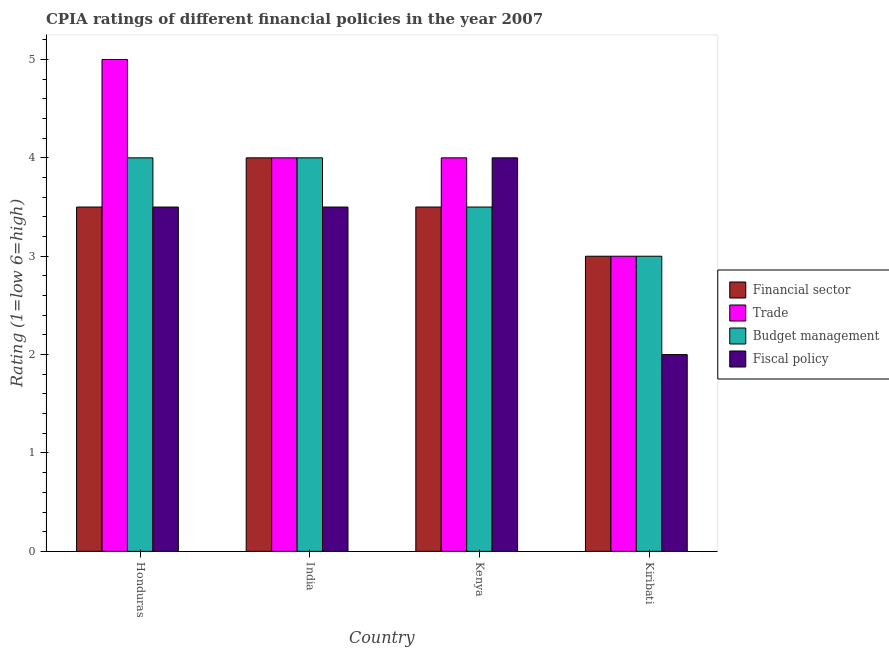How many different coloured bars are there?
Your answer should be compact. 4. Are the number of bars per tick equal to the number of legend labels?
Offer a terse response. Yes. Are the number of bars on each tick of the X-axis equal?
Your answer should be very brief. Yes. How many bars are there on the 1st tick from the left?
Provide a succinct answer. 4. How many bars are there on the 3rd tick from the right?
Keep it short and to the point. 4. What is the label of the 4th group of bars from the left?
Offer a terse response. Kiribati. In how many cases, is the number of bars for a given country not equal to the number of legend labels?
Your answer should be very brief. 0. What is the cpia rating of budget management in Kenya?
Ensure brevity in your answer.  3.5. Across all countries, what is the maximum cpia rating of fiscal policy?
Offer a very short reply. 4. In which country was the cpia rating of fiscal policy maximum?
Your answer should be very brief. Kenya. In which country was the cpia rating of fiscal policy minimum?
Your response must be concise. Kiribati. What is the total cpia rating of budget management in the graph?
Keep it short and to the point. 14.5. What is the difference between the cpia rating of budget management in Kiribati and the cpia rating of trade in India?
Offer a very short reply. -1. What is the difference between the cpia rating of financial sector and cpia rating of budget management in Honduras?
Your answer should be compact. -0.5. What is the ratio of the cpia rating of budget management in Honduras to that in Kenya?
Keep it short and to the point. 1.14. In how many countries, is the cpia rating of budget management greater than the average cpia rating of budget management taken over all countries?
Offer a very short reply. 2. Is the sum of the cpia rating of financial sector in Honduras and Kiribati greater than the maximum cpia rating of fiscal policy across all countries?
Provide a short and direct response. Yes. What does the 4th bar from the left in Honduras represents?
Provide a succinct answer. Fiscal policy. What does the 1st bar from the right in Kiribati represents?
Your response must be concise. Fiscal policy. How many bars are there?
Provide a succinct answer. 16. Are all the bars in the graph horizontal?
Provide a succinct answer. No. Does the graph contain any zero values?
Offer a very short reply. No. How are the legend labels stacked?
Your answer should be compact. Vertical. What is the title of the graph?
Keep it short and to the point. CPIA ratings of different financial policies in the year 2007. Does "Secondary" appear as one of the legend labels in the graph?
Keep it short and to the point. No. What is the label or title of the Y-axis?
Your response must be concise. Rating (1=low 6=high). What is the Rating (1=low 6=high) in Budget management in Honduras?
Provide a short and direct response. 4. What is the Rating (1=low 6=high) of Fiscal policy in Honduras?
Make the answer very short. 3.5. What is the Rating (1=low 6=high) of Trade in India?
Give a very brief answer. 4. What is the Rating (1=low 6=high) of Budget management in India?
Your answer should be very brief. 4. What is the Rating (1=low 6=high) in Financial sector in Kenya?
Your answer should be compact. 3.5. What is the Rating (1=low 6=high) of Budget management in Kenya?
Make the answer very short. 3.5. Across all countries, what is the maximum Rating (1=low 6=high) of Fiscal policy?
Provide a short and direct response. 4. Across all countries, what is the minimum Rating (1=low 6=high) in Financial sector?
Offer a very short reply. 3. Across all countries, what is the minimum Rating (1=low 6=high) in Trade?
Ensure brevity in your answer.  3. What is the total Rating (1=low 6=high) in Budget management in the graph?
Your response must be concise. 14.5. What is the total Rating (1=low 6=high) in Fiscal policy in the graph?
Provide a succinct answer. 13. What is the difference between the Rating (1=low 6=high) in Financial sector in Honduras and that in India?
Provide a succinct answer. -0.5. What is the difference between the Rating (1=low 6=high) of Fiscal policy in Honduras and that in India?
Give a very brief answer. 0. What is the difference between the Rating (1=low 6=high) of Trade in Honduras and that in Kenya?
Make the answer very short. 1. What is the difference between the Rating (1=low 6=high) in Budget management in Honduras and that in Kenya?
Offer a very short reply. 0.5. What is the difference between the Rating (1=low 6=high) in Fiscal policy in Honduras and that in Kenya?
Your response must be concise. -0.5. What is the difference between the Rating (1=low 6=high) in Financial sector in Honduras and that in Kiribati?
Ensure brevity in your answer.  0.5. What is the difference between the Rating (1=low 6=high) of Trade in Honduras and that in Kiribati?
Give a very brief answer. 2. What is the difference between the Rating (1=low 6=high) in Budget management in Honduras and that in Kiribati?
Your answer should be very brief. 1. What is the difference between the Rating (1=low 6=high) of Budget management in India and that in Kenya?
Make the answer very short. 0.5. What is the difference between the Rating (1=low 6=high) of Financial sector in India and that in Kiribati?
Your answer should be compact. 1. What is the difference between the Rating (1=low 6=high) of Budget management in India and that in Kiribati?
Keep it short and to the point. 1. What is the difference between the Rating (1=low 6=high) of Financial sector in Kenya and that in Kiribati?
Provide a succinct answer. 0.5. What is the difference between the Rating (1=low 6=high) in Fiscal policy in Kenya and that in Kiribati?
Your answer should be compact. 2. What is the difference between the Rating (1=low 6=high) of Financial sector in Honduras and the Rating (1=low 6=high) of Trade in India?
Offer a very short reply. -0.5. What is the difference between the Rating (1=low 6=high) of Trade in Honduras and the Rating (1=low 6=high) of Budget management in India?
Offer a terse response. 1. What is the difference between the Rating (1=low 6=high) of Trade in Honduras and the Rating (1=low 6=high) of Fiscal policy in India?
Provide a short and direct response. 1.5. What is the difference between the Rating (1=low 6=high) in Financial sector in Honduras and the Rating (1=low 6=high) in Fiscal policy in Kenya?
Offer a very short reply. -0.5. What is the difference between the Rating (1=low 6=high) in Trade in Honduras and the Rating (1=low 6=high) in Budget management in Kenya?
Your answer should be compact. 1.5. What is the difference between the Rating (1=low 6=high) in Financial sector in Honduras and the Rating (1=low 6=high) in Trade in Kiribati?
Make the answer very short. 0.5. What is the difference between the Rating (1=low 6=high) in Trade in Honduras and the Rating (1=low 6=high) in Fiscal policy in Kiribati?
Provide a succinct answer. 3. What is the difference between the Rating (1=low 6=high) of Budget management in Honduras and the Rating (1=low 6=high) of Fiscal policy in Kiribati?
Your answer should be compact. 2. What is the difference between the Rating (1=low 6=high) of Financial sector in India and the Rating (1=low 6=high) of Budget management in Kenya?
Offer a very short reply. 0.5. What is the difference between the Rating (1=low 6=high) in Trade in India and the Rating (1=low 6=high) in Budget management in Kenya?
Provide a short and direct response. 0.5. What is the difference between the Rating (1=low 6=high) of Trade in India and the Rating (1=low 6=high) of Budget management in Kiribati?
Make the answer very short. 1. What is the difference between the Rating (1=low 6=high) of Trade in India and the Rating (1=low 6=high) of Fiscal policy in Kiribati?
Offer a very short reply. 2. What is the difference between the Rating (1=low 6=high) in Budget management in India and the Rating (1=low 6=high) in Fiscal policy in Kiribati?
Ensure brevity in your answer.  2. What is the difference between the Rating (1=low 6=high) of Trade in Kenya and the Rating (1=low 6=high) of Budget management in Kiribati?
Your response must be concise. 1. What is the difference between the Rating (1=low 6=high) of Budget management in Kenya and the Rating (1=low 6=high) of Fiscal policy in Kiribati?
Your answer should be very brief. 1.5. What is the average Rating (1=low 6=high) of Financial sector per country?
Your answer should be compact. 3.5. What is the average Rating (1=low 6=high) in Budget management per country?
Offer a very short reply. 3.62. What is the average Rating (1=low 6=high) in Fiscal policy per country?
Your answer should be very brief. 3.25. What is the difference between the Rating (1=low 6=high) in Financial sector and Rating (1=low 6=high) in Budget management in Honduras?
Provide a succinct answer. -0.5. What is the difference between the Rating (1=low 6=high) in Trade and Rating (1=low 6=high) in Budget management in Honduras?
Your answer should be compact. 1. What is the difference between the Rating (1=low 6=high) in Budget management and Rating (1=low 6=high) in Fiscal policy in Honduras?
Keep it short and to the point. 0.5. What is the difference between the Rating (1=low 6=high) in Trade and Rating (1=low 6=high) in Fiscal policy in India?
Offer a terse response. 0.5. What is the difference between the Rating (1=low 6=high) of Financial sector and Rating (1=low 6=high) of Trade in Kenya?
Offer a very short reply. -0.5. What is the difference between the Rating (1=low 6=high) in Financial sector and Rating (1=low 6=high) in Budget management in Kenya?
Offer a very short reply. 0. What is the difference between the Rating (1=low 6=high) in Financial sector and Rating (1=low 6=high) in Fiscal policy in Kenya?
Provide a succinct answer. -0.5. What is the difference between the Rating (1=low 6=high) in Financial sector and Rating (1=low 6=high) in Fiscal policy in Kiribati?
Your answer should be very brief. 1. What is the difference between the Rating (1=low 6=high) of Trade and Rating (1=low 6=high) of Fiscal policy in Kiribati?
Make the answer very short. 1. What is the ratio of the Rating (1=low 6=high) of Budget management in Honduras to that in India?
Offer a terse response. 1. What is the ratio of the Rating (1=low 6=high) in Fiscal policy in Honduras to that in India?
Ensure brevity in your answer.  1. What is the ratio of the Rating (1=low 6=high) in Financial sector in Honduras to that in Kenya?
Offer a very short reply. 1. What is the ratio of the Rating (1=low 6=high) of Trade in Honduras to that in Kenya?
Give a very brief answer. 1.25. What is the ratio of the Rating (1=low 6=high) of Fiscal policy in Honduras to that in Kenya?
Give a very brief answer. 0.88. What is the ratio of the Rating (1=low 6=high) in Trade in Honduras to that in Kiribati?
Your answer should be compact. 1.67. What is the ratio of the Rating (1=low 6=high) of Fiscal policy in India to that in Kenya?
Your answer should be very brief. 0.88. What is the ratio of the Rating (1=low 6=high) in Financial sector in India to that in Kiribati?
Offer a terse response. 1.33. What is the ratio of the Rating (1=low 6=high) in Budget management in India to that in Kiribati?
Your response must be concise. 1.33. What is the ratio of the Rating (1=low 6=high) in Financial sector in Kenya to that in Kiribati?
Your answer should be very brief. 1.17. What is the ratio of the Rating (1=low 6=high) of Trade in Kenya to that in Kiribati?
Give a very brief answer. 1.33. What is the difference between the highest and the second highest Rating (1=low 6=high) in Financial sector?
Provide a short and direct response. 0.5. What is the difference between the highest and the second highest Rating (1=low 6=high) in Budget management?
Ensure brevity in your answer.  0. What is the difference between the highest and the second highest Rating (1=low 6=high) in Fiscal policy?
Provide a succinct answer. 0.5. What is the difference between the highest and the lowest Rating (1=low 6=high) of Fiscal policy?
Make the answer very short. 2. 